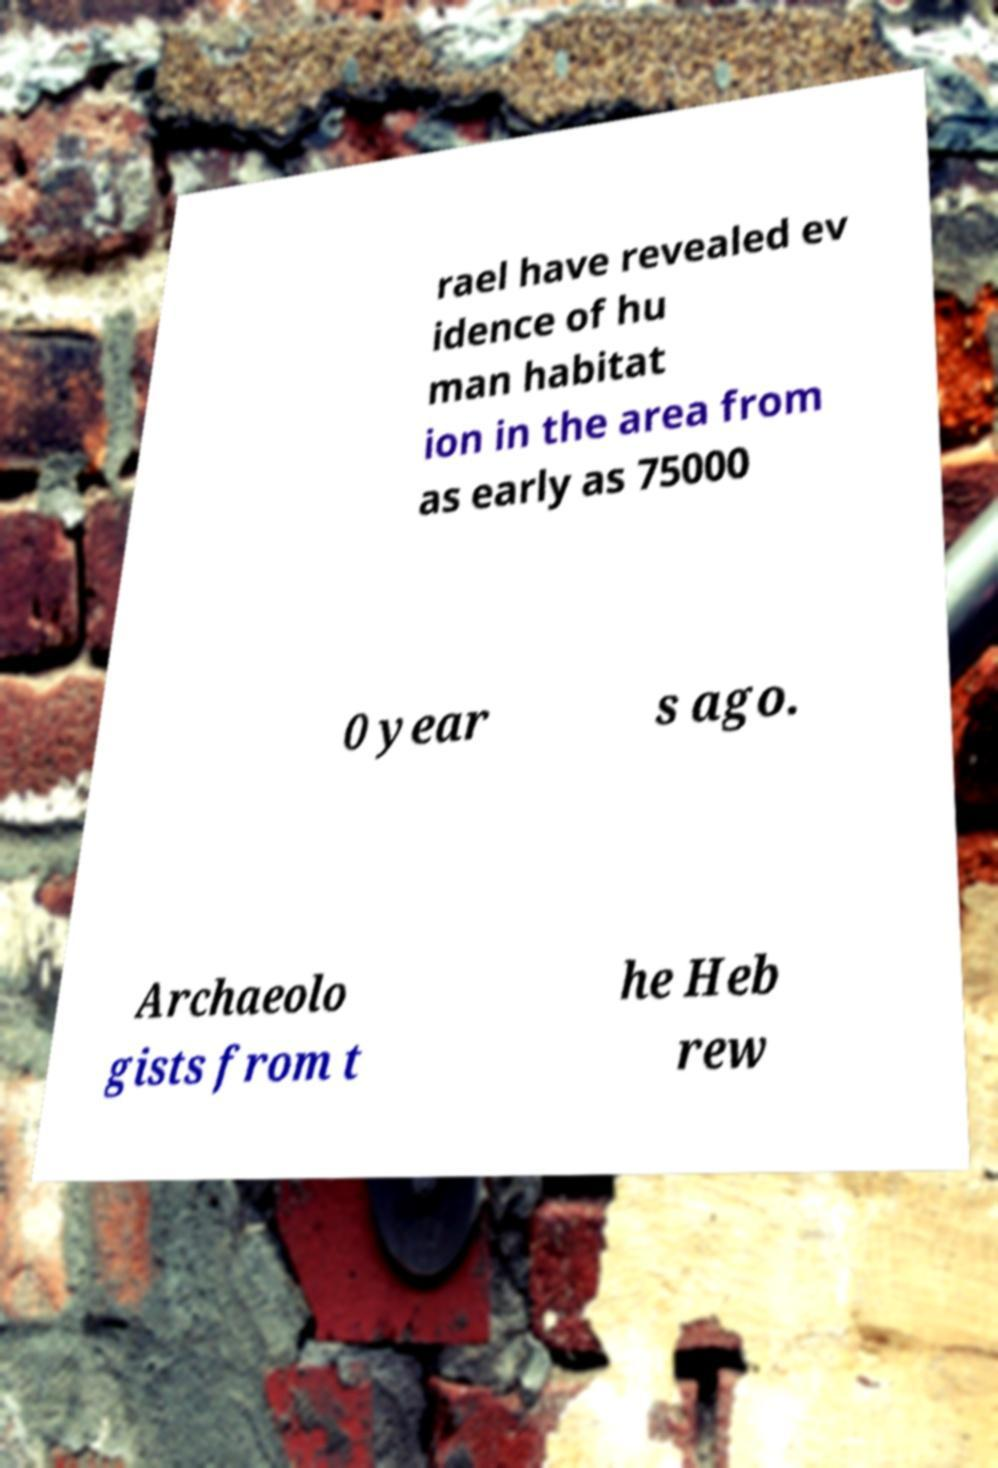Can you accurately transcribe the text from the provided image for me? rael have revealed ev idence of hu man habitat ion in the area from as early as 75000 0 year s ago. Archaeolo gists from t he Heb rew 